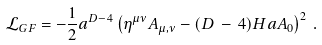Convert formula to latex. <formula><loc_0><loc_0><loc_500><loc_500>\mathcal { L } _ { G F } = - \frac { 1 } { 2 } a ^ { D - 4 } \left ( \eta ^ { \mu \nu } A _ { \mu , \nu } - ( D \, - \, 4 ) H a A _ { 0 } \right ) ^ { 2 } \, .</formula> 